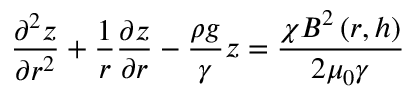Convert formula to latex. <formula><loc_0><loc_0><loc_500><loc_500>\frac { \partial ^ { 2 } z } { \partial r ^ { 2 } } + \frac { 1 } { r } \frac { \partial z } { \partial r } - \frac { \rho g } { \gamma } z = \frac { \chi B ^ { 2 } \left ( r , h \right ) } { 2 \mu _ { 0 } \gamma }</formula> 